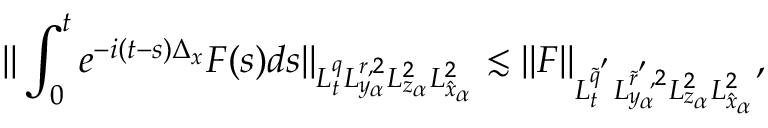Convert formula to latex. <formula><loc_0><loc_0><loc_500><loc_500>\| \int _ { 0 } ^ { t } e ^ { - i ( t - s ) \Delta _ { x } } F ( s ) d s \| _ { L _ { t } ^ { q } L _ { y _ { \alpha } } ^ { r , 2 } L _ { z _ { \alpha } } ^ { 2 } L _ { \hat { x } _ { \alpha } } ^ { 2 } } \lesssim \| F \| _ { L _ { t } ^ { \tilde { q } ^ { ^ { \prime } } } L _ { y _ { \alpha } } ^ { \tilde { r } ^ { ^ { \prime } } , 2 } L _ { z _ { \alpha } } ^ { 2 } L _ { \hat { x } _ { \alpha } } ^ { 2 } } ,</formula> 